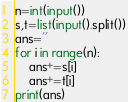Convert code to text. <code><loc_0><loc_0><loc_500><loc_500><_Python_>n=int(input())
s,t=list(input().split())
ans=''
for i in range(n):
    ans+=s[i]
    ans+=t[i]
print(ans)</code> 